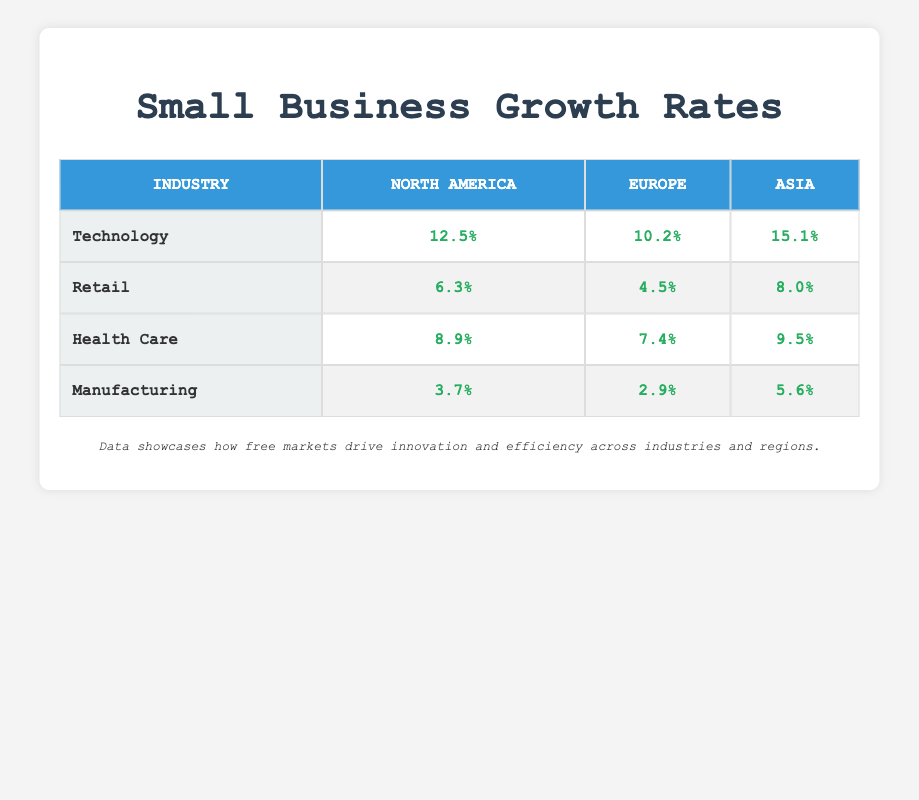What is the growth rate for the Technology industry in North America? The table lists the growth rate for the Technology industry under the North America column as 12.5%.
Answer: 12.5% Which region has the highest growth rate for the Retail industry? By comparing the growth rates of the Retail industry across North America (6.3%), Europe (4.5%), and Asia (8.0%), Asia has the highest growth rate at 8.0%.
Answer: Asia What is the difference in growth rates for Health Care between North America and Europe? The growth rate for Health Care in North America is 8.9% and in Europe it is 7.4%. The difference is calculated by subtracting 7.4 from 8.9, which equals 1.5%.
Answer: 1.5% Is it true that the Manufacturing industry has a higher growth rate in North America than in Europe? The growth rates for Manufacturing are 3.7% in North America and 2.9% in Europe. Since 3.7% is greater than 2.9%, the statement is true.
Answer: Yes What is the combined growth rate for Technology across all regions? The growth rates for Technology are 12.5% in North America, 10.2% in Europe, and 15.1% in Asia. To find the combined total, we add these rates: 12.5 + 10.2 + 15.1 = 37.8%. To find the average, we divide 37.8 by 3 (the number of regions), resulting in an average growth rate of 12.6%.
Answer: 12.6% 